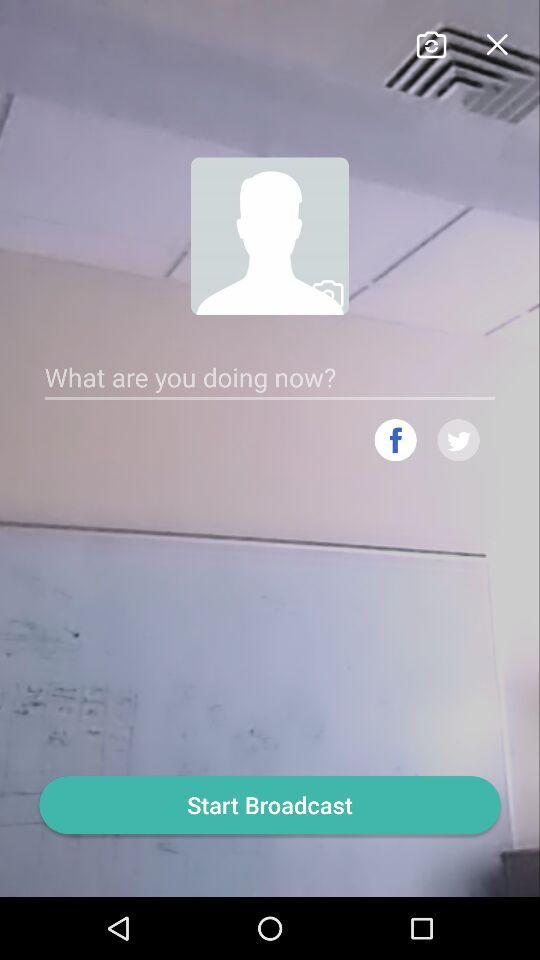How many social media platforms are there to choose from?
Answer the question using a single word or phrase. 2 